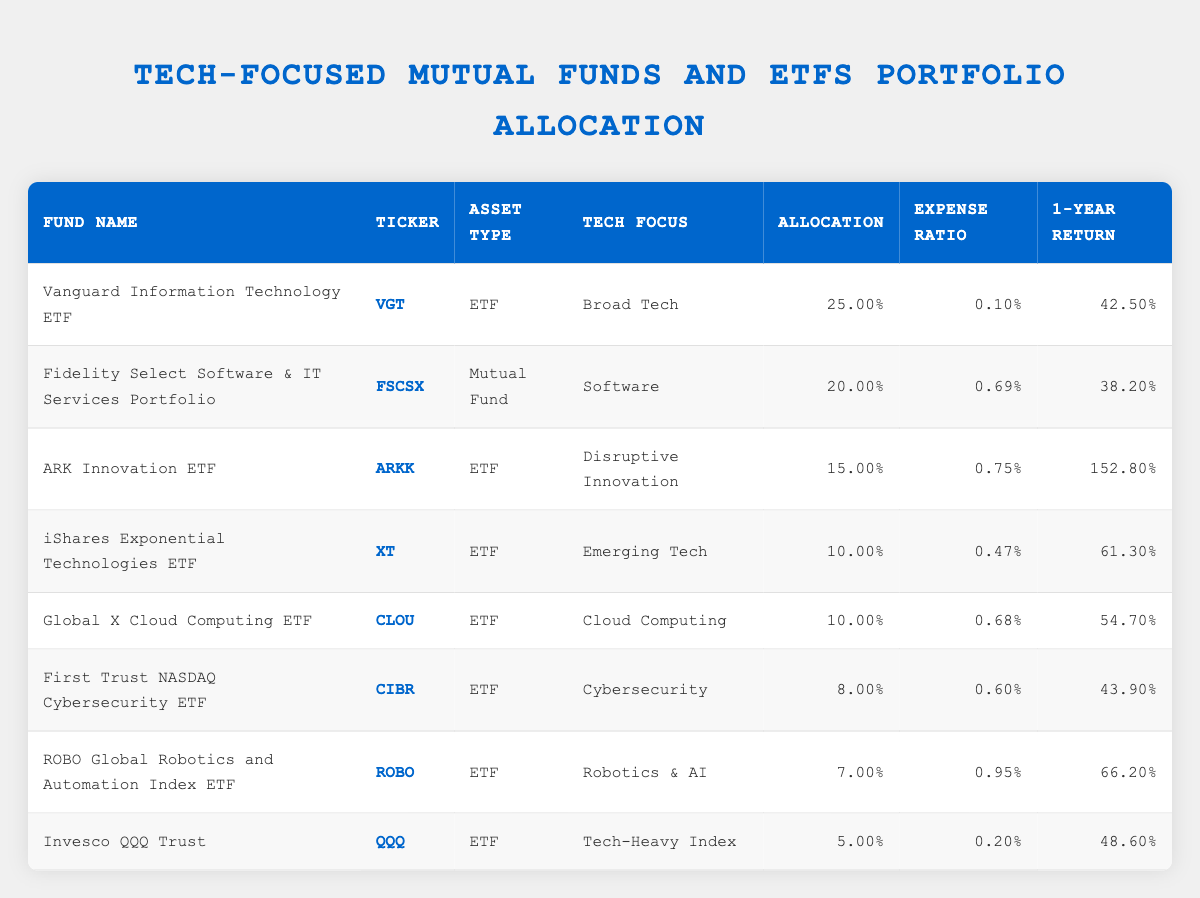What is the expense ratio for ARK Innovation ETF? The expense ratio for ARK Innovation ETF is listed in the table under the corresponding column for that fund. I locate ARK Innovation ETF and read the expense ratio next to it, which is 0.75%.
Answer: 0.75 Which fund has the highest 1-year return? To find the fund with the highest 1-year return, I review the 1-Year Return column, finding ARK Innovation ETF with a return of 152.8%.
Answer: ARK Innovation ETF What is the total allocation percentage for ETFs listed in the table? I identify that there are 6 ETFs in the table, and their allocations are 25%, 15%, 10%, 10%, 8%, and 5%. I add these values together: 25 + 15 + 10 + 10 + 8 + 5 = 73. The total allocation percentage for ETFs is therefore 73%.
Answer: 73 Is the expense ratio for the Vanguard Information Technology ETF lower than 0.50%? I find the expense ratio for Vanguard Information Technology ETF, which is 0.10%. Since 0.10% is indeed lower than 0.50%, the statement is true.
Answer: Yes What is the average 1-year return for the funds focusing on Software and Cloud Computing? I first locate the 1-Year Return for Fidelity Select Software & IT Services Portfolio (38.2%) and Global X Cloud Computing ETF (54.7%). I then calculate their average: (38.2 + 54.7) / 2 = 46.45. Therefore, the average 1-year return for these funds is 46.45%.
Answer: 46.45 Is it true that all funds focusing on Emerging Tech have an allocation percentage greater than 10%? I check the allocation percentage for iShares Exponential Technologies ETF, which is 10%. Since it is not greater than 10%, the statement is false.
Answer: No What percentage of the portfolio is allocated to Cybersecurity and Robotics & AI combined? I identify the allocations for First Trust NASDAQ Cybersecurity ETF (8%) and ROBO Global Robotics and Automation Index ETF (7%). I sum these allocations: 8 + 7 = 15. Thus, the combined allocation for these two focuses is 15%.
Answer: 15 Which fund has the lowest allocation percentage and what is its value? I look through the Allocation column and find that Invesco QQQ Trust has the lowest allocation percentage of 5%.
Answer: 5 